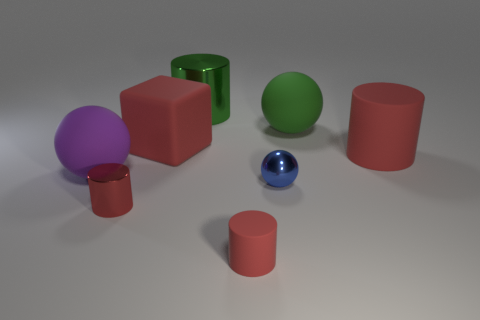Subtract 1 balls. How many balls are left? 2 Subtract all green cylinders. How many cylinders are left? 3 Subtract all gray spheres. How many red cylinders are left? 3 Subtract all small red rubber cylinders. How many cylinders are left? 3 Add 1 big green objects. How many objects exist? 9 Subtract all brown cylinders. Subtract all cyan cubes. How many cylinders are left? 4 Add 2 red rubber things. How many red rubber things exist? 5 Subtract 0 red balls. How many objects are left? 8 Subtract all cubes. How many objects are left? 7 Subtract all tiny shiny objects. Subtract all big green matte spheres. How many objects are left? 5 